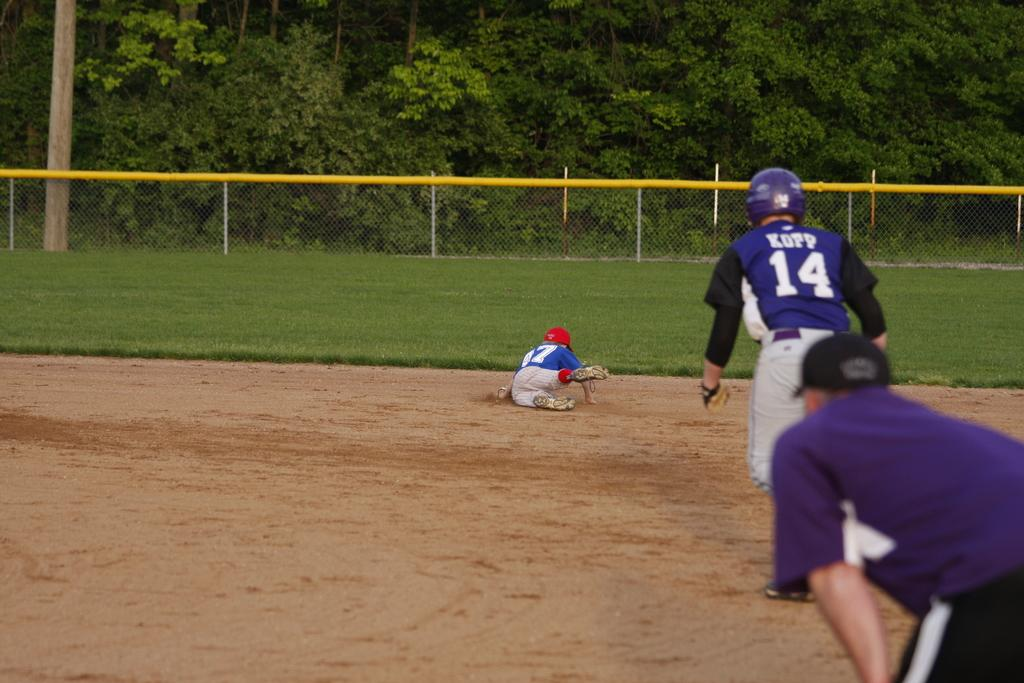<image>
Create a compact narrative representing the image presented. a player that has the number 14 on them 